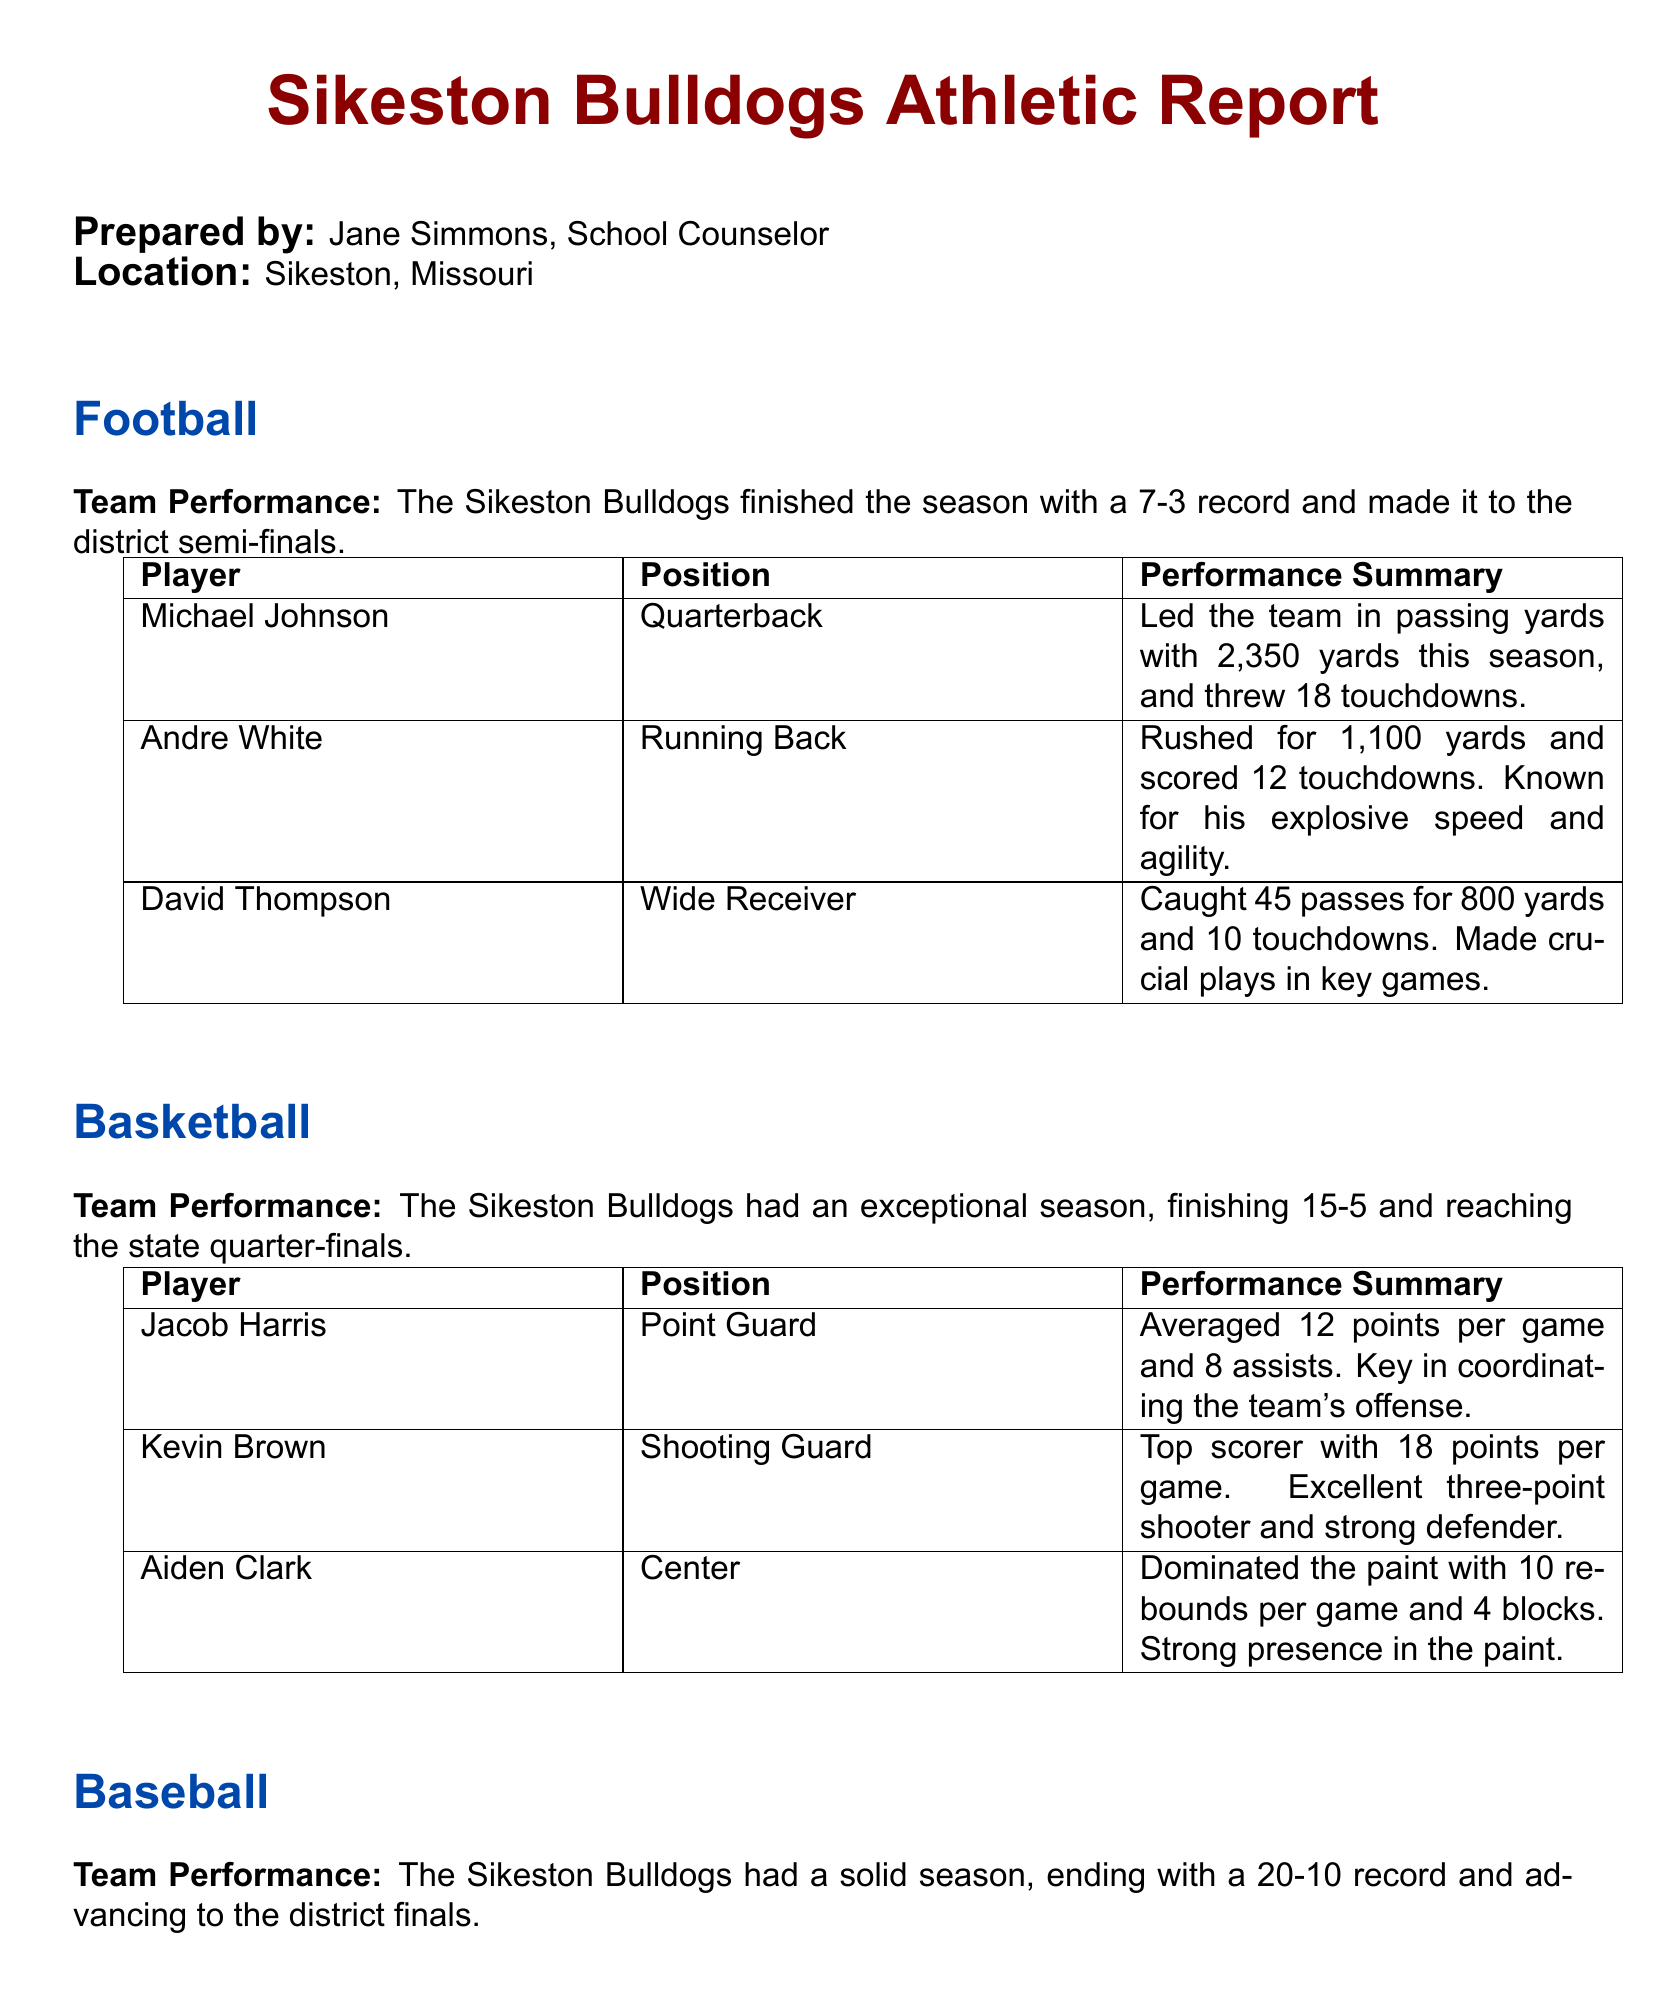What was the Sikeston Bulldogs' football season record? The football season record is explicitly listed in the document.
Answer: 7-3 Who is the top scorer on the basketball team? The top scorer's name and position are included in the performance summary for basketball.
Answer: Kevin Brown How many touchdowns did Michael Johnson throw this season? This information is provided in the performance summary for Michael Johnson.
Answer: 18 What is William Roberts' ERA as a pitcher? The ERA is mentioned alongside his performance details.
Answer: 2.75 How many rebounds did Aiden Clark average per game? The average rebounds per game for Aiden Clark is given in the basketball section.
Answer: 10 How many home runs did James Anderson hit this season? This information is found in the summary of James Anderson's performance.
Answer: 5 What round did the football team reach in the playoffs? The playoff round is stated in the team's performance summary.
Answer: District semi-finals How many assists did Jacob Harris average per game? This detail is included in Jacob Harris' performance summary for basketball.
Answer: 8 What distinguishes Andre White as a running back? The summary mentions specific qualities that set Andre White apart.
Answer: Explosive speed and agility 